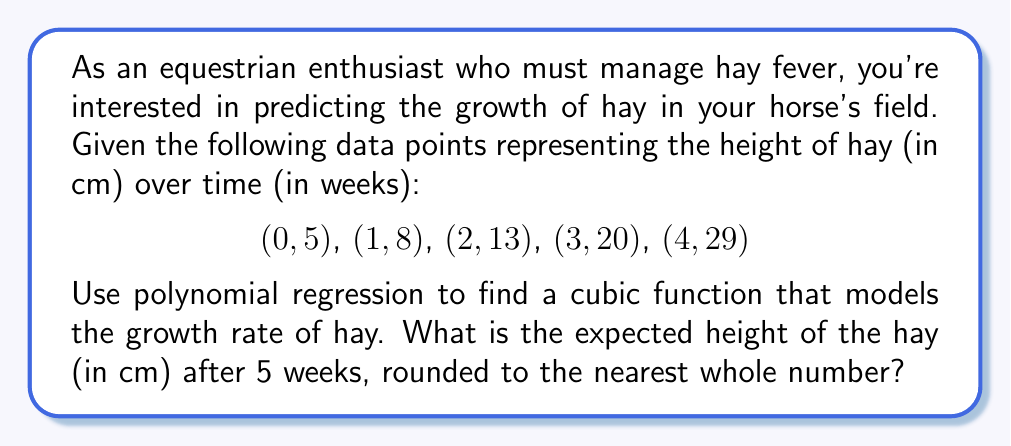Can you answer this question? To solve this problem, we'll use cubic polynomial regression to fit a function of the form:

$$f(x) = ax^3 + bx^2 + cx + d$$

where $x$ represents the number of weeks and $f(x)$ represents the height of hay in cm.

1) First, we set up a system of equations using the given data points:

   $$5 = d$$
   $$8 = a + b + c + d$$
   $$13 = 8a + 4b + 2c + d$$
   $$20 = 27a + 9b + 3c + d$$
   $$29 = 64a + 16b + 4c + d$$

2) Subtract the first equation from the others to eliminate $d$:

   $$3 = a + b + c$$
   $$8 = 8a + 4b + 2c$$
   $$15 = 27a + 9b + 3c$$
   $$24 = 64a + 16b + 4c$$

3) Use a computer algebra system or matrix operations to solve this system of equations. The solution is:

   $$a = 0.5$$
   $$b = -0.5$$
   $$c = 3$$
   $$d = 5$$

4) Therefore, our cubic function is:

   $$f(x) = 0.5x^3 - 0.5x^2 + 3x + 5$$

5) To find the height after 5 weeks, we evaluate $f(5)$:

   $$f(5) = 0.5(5^3) - 0.5(5^2) + 3(5) + 5$$
   $$= 0.5(125) - 0.5(25) + 15 + 5$$
   $$= 62.5 - 12.5 + 15 + 5$$
   $$= 70$$

6) Rounding to the nearest whole number, we get 70 cm.
Answer: 70 cm 